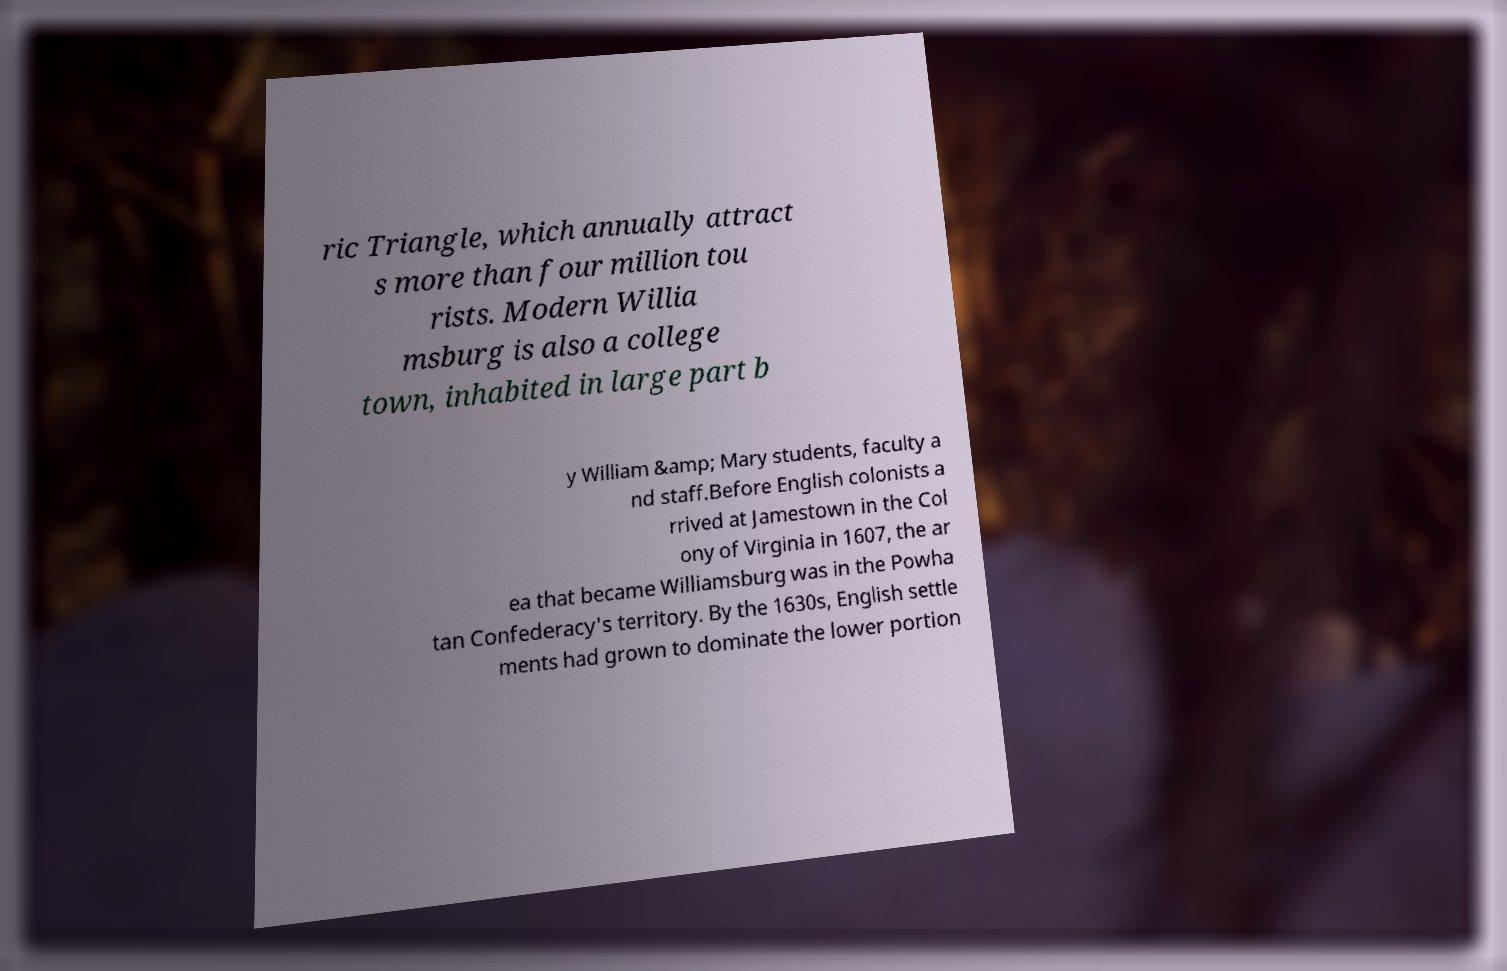For documentation purposes, I need the text within this image transcribed. Could you provide that? ric Triangle, which annually attract s more than four million tou rists. Modern Willia msburg is also a college town, inhabited in large part b y William &amp; Mary students, faculty a nd staff.Before English colonists a rrived at Jamestown in the Col ony of Virginia in 1607, the ar ea that became Williamsburg was in the Powha tan Confederacy's territory. By the 1630s, English settle ments had grown to dominate the lower portion 